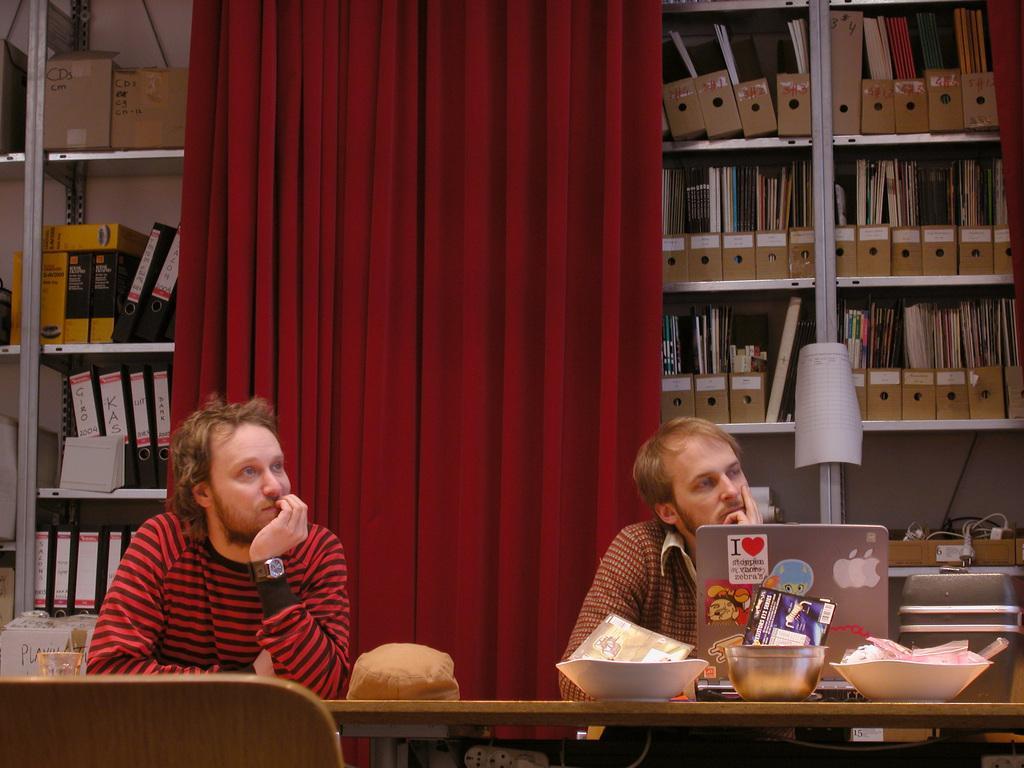Could you give a brief overview of what you see in this image? In this image we can see two men sitting on the chairs and a table is placed in front of them. On the table there are bowls, laptop and a paper carton. In the background we can see files and books arranged in rows and a curtain. 